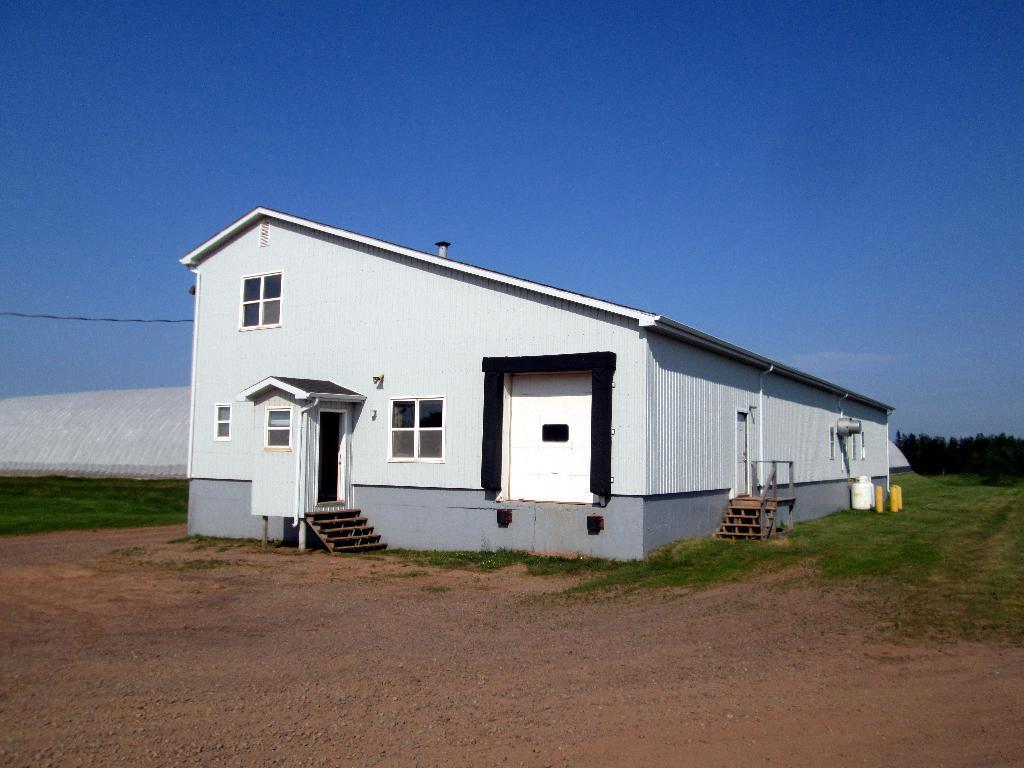What type of structure is in the image? There is a house in the image. What type of vegetation is beside the house? There is grass beside the house. What utility is visible in the image? There is a cable visible in the image. What can be seen in the background of the image? There are trees and a shed in the background of the image. How many knives are on the roof of the house in the image? There are no knives visible on the roof of the house in the image. What is the fifth object in the image? The provided facts do not mention a fifth object in the image. 